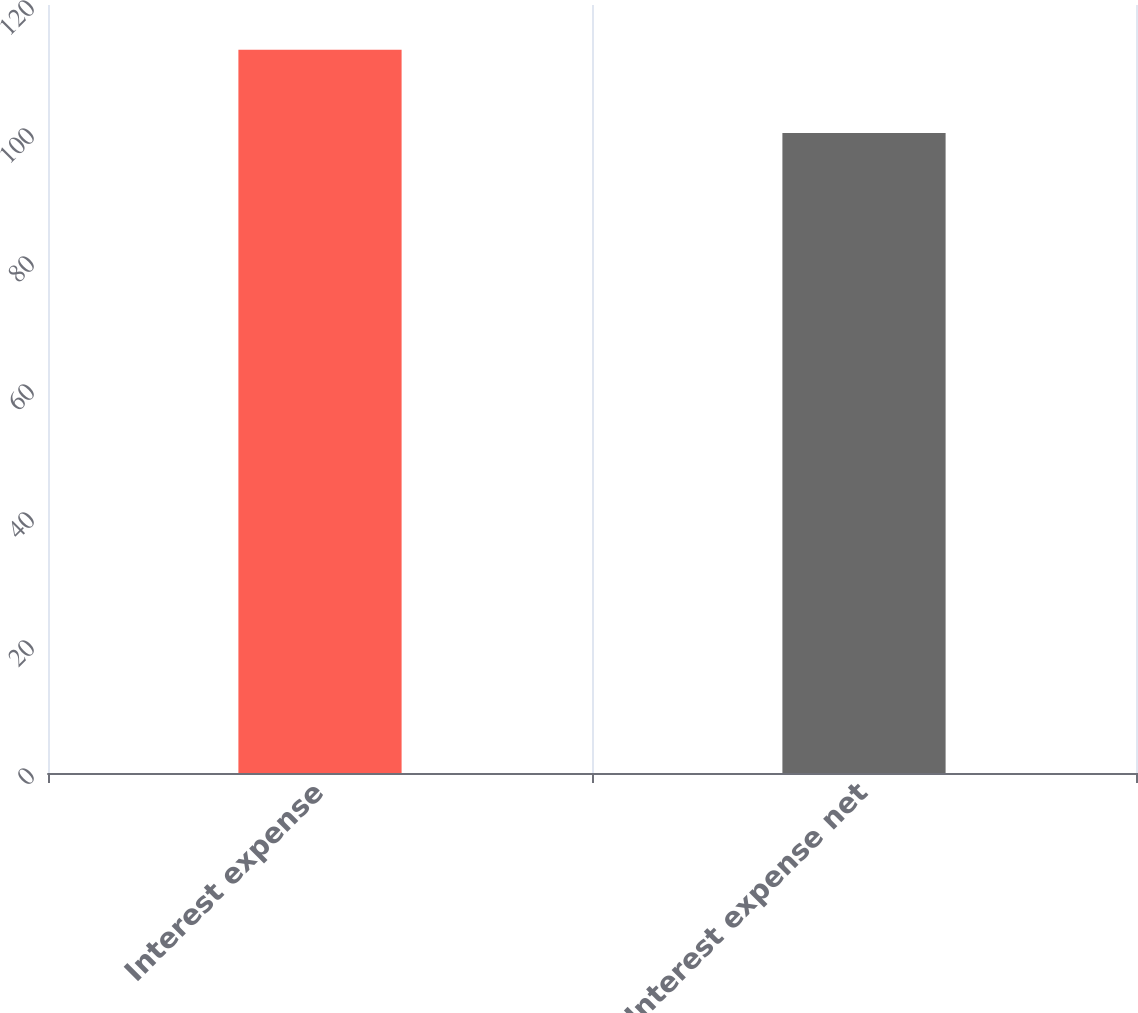<chart> <loc_0><loc_0><loc_500><loc_500><bar_chart><fcel>Interest expense<fcel>Interest expense net<nl><fcel>113<fcel>100<nl></chart> 